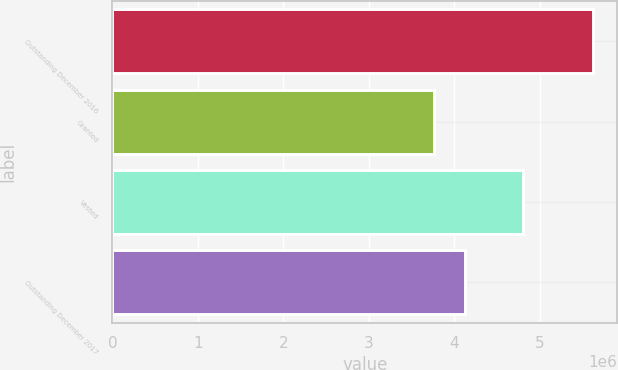Convert chart to OTSL. <chart><loc_0><loc_0><loc_500><loc_500><bar_chart><fcel>Outstanding December 2016<fcel>Granted<fcel>Vested<fcel>Outstanding December 2017<nl><fcel>5.62324e+06<fcel>3.7644e+06<fcel>4.79734e+06<fcel>4.12358e+06<nl></chart> 